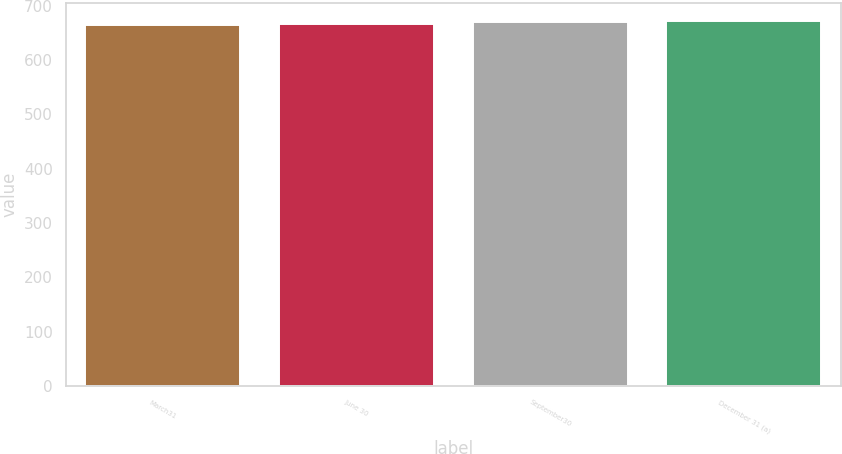Convert chart to OTSL. <chart><loc_0><loc_0><loc_500><loc_500><bar_chart><fcel>March31<fcel>June 30<fcel>September30<fcel>December 31 (a)<nl><fcel>665<fcel>667<fcel>669<fcel>672<nl></chart> 